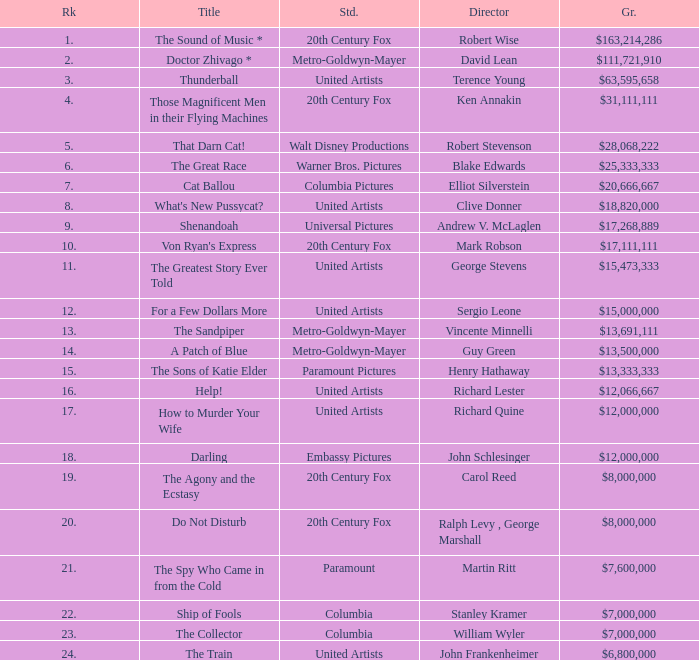What is the highest Rank, when Director is "Henry Hathaway"? 15.0. Could you help me parse every detail presented in this table? {'header': ['Rk', 'Title', 'Std.', 'Director', 'Gr.'], 'rows': [['1.', 'The Sound of Music *', '20th Century Fox', 'Robert Wise', '$163,214,286'], ['2.', 'Doctor Zhivago *', 'Metro-Goldwyn-Mayer', 'David Lean', '$111,721,910'], ['3.', 'Thunderball', 'United Artists', 'Terence Young', '$63,595,658'], ['4.', 'Those Magnificent Men in their Flying Machines', '20th Century Fox', 'Ken Annakin', '$31,111,111'], ['5.', 'That Darn Cat!', 'Walt Disney Productions', 'Robert Stevenson', '$28,068,222'], ['6.', 'The Great Race', 'Warner Bros. Pictures', 'Blake Edwards', '$25,333,333'], ['7.', 'Cat Ballou', 'Columbia Pictures', 'Elliot Silverstein', '$20,666,667'], ['8.', "What's New Pussycat?", 'United Artists', 'Clive Donner', '$18,820,000'], ['9.', 'Shenandoah', 'Universal Pictures', 'Andrew V. McLaglen', '$17,268,889'], ['10.', "Von Ryan's Express", '20th Century Fox', 'Mark Robson', '$17,111,111'], ['11.', 'The Greatest Story Ever Told', 'United Artists', 'George Stevens', '$15,473,333'], ['12.', 'For a Few Dollars More', 'United Artists', 'Sergio Leone', '$15,000,000'], ['13.', 'The Sandpiper', 'Metro-Goldwyn-Mayer', 'Vincente Minnelli', '$13,691,111'], ['14.', 'A Patch of Blue', 'Metro-Goldwyn-Mayer', 'Guy Green', '$13,500,000'], ['15.', 'The Sons of Katie Elder', 'Paramount Pictures', 'Henry Hathaway', '$13,333,333'], ['16.', 'Help!', 'United Artists', 'Richard Lester', '$12,066,667'], ['17.', 'How to Murder Your Wife', 'United Artists', 'Richard Quine', '$12,000,000'], ['18.', 'Darling', 'Embassy Pictures', 'John Schlesinger', '$12,000,000'], ['19.', 'The Agony and the Ecstasy', '20th Century Fox', 'Carol Reed', '$8,000,000'], ['20.', 'Do Not Disturb', '20th Century Fox', 'Ralph Levy , George Marshall', '$8,000,000'], ['21.', 'The Spy Who Came in from the Cold', 'Paramount', 'Martin Ritt', '$7,600,000'], ['22.', 'Ship of Fools', 'Columbia', 'Stanley Kramer', '$7,000,000'], ['23.', 'The Collector', 'Columbia', 'William Wyler', '$7,000,000'], ['24.', 'The Train', 'United Artists', 'John Frankenheimer', '$6,800,000']]} 